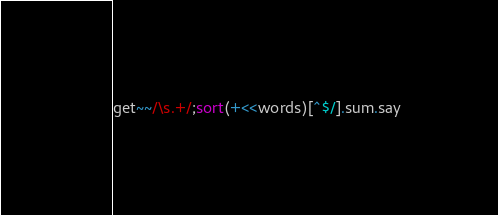Convert code to text. <code><loc_0><loc_0><loc_500><loc_500><_Perl_>get~~/\s.+/;sort(+<<words)[^$/].sum.say</code> 